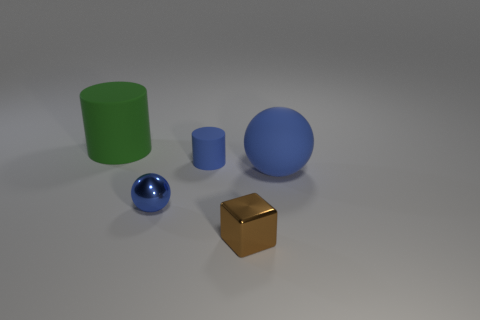There is a blue cylinder that is the same size as the brown block; what is it made of?
Give a very brief answer. Rubber. Are there any brown cubes made of the same material as the big cylinder?
Offer a terse response. No. There is a object that is both to the left of the small cylinder and on the right side of the large green matte thing; what color is it?
Ensure brevity in your answer.  Blue. How many other things are there of the same color as the small metallic sphere?
Your response must be concise. 2. What is the material of the blue ball to the left of the big thing that is to the right of the matte object on the left side of the small ball?
Offer a very short reply. Metal. How many blocks are either brown rubber things or blue metal things?
Provide a short and direct response. 0. Are there any other things that have the same size as the green thing?
Your answer should be very brief. Yes. How many brown metal blocks are behind the large thing on the right side of the green rubber thing that is behind the brown cube?
Provide a succinct answer. 0. Do the large green object and the small brown metal thing have the same shape?
Give a very brief answer. No. Do the large thing that is to the left of the small brown cube and the tiny blue object in front of the small cylinder have the same material?
Offer a very short reply. No. 